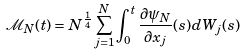Convert formula to latex. <formula><loc_0><loc_0><loc_500><loc_500>\mathcal { M } _ { N } ( t ) = N ^ { \frac { 1 } { 4 } } \sum _ { j = 1 } ^ { N } \int _ { 0 } ^ { t } \frac { \partial \psi _ { N } } { \partial x _ { j } } ( s ) d W _ { j } ( s )</formula> 